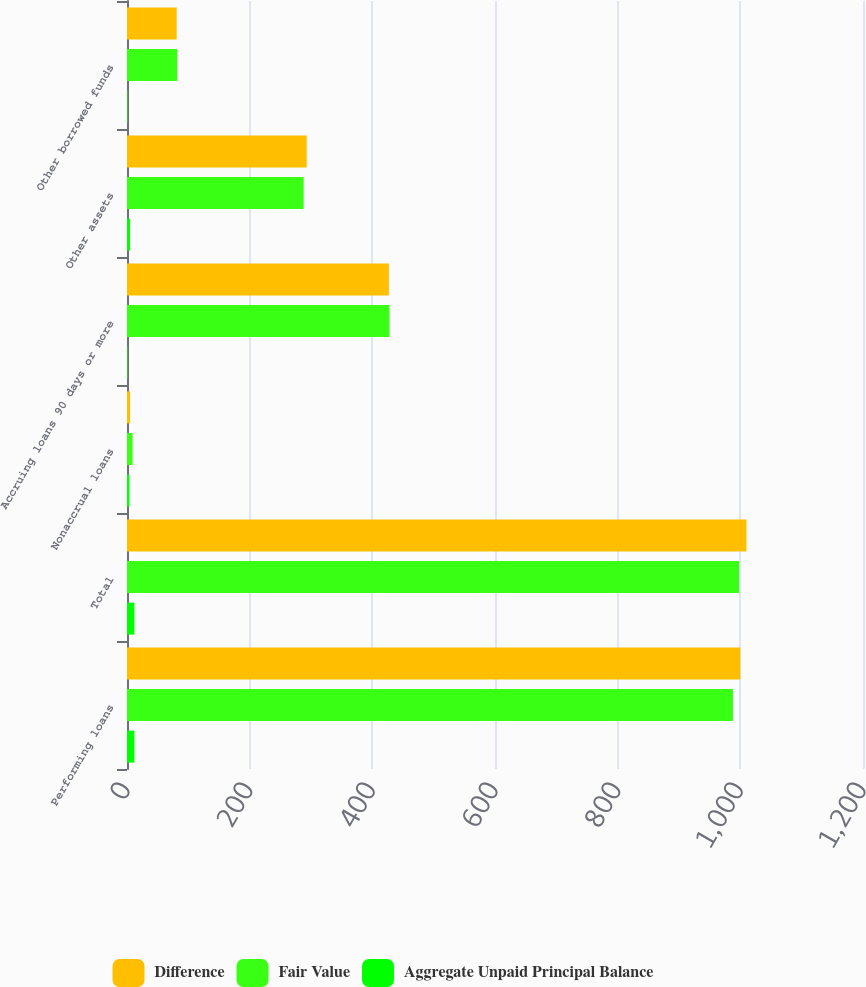Convert chart to OTSL. <chart><loc_0><loc_0><loc_500><loc_500><stacked_bar_chart><ecel><fcel>Performing loans<fcel>Total<fcel>Nonaccrual loans<fcel>Accruing loans 90 days or more<fcel>Other assets<fcel>Other borrowed funds<nl><fcel>Difference<fcel>1000<fcel>1010<fcel>5<fcel>427<fcel>293<fcel>81<nl><fcel>Fair Value<fcel>988<fcel>998<fcel>9<fcel>428<fcel>288<fcel>82<nl><fcel>Aggregate Unpaid Principal Balance<fcel>12<fcel>12<fcel>4<fcel>1<fcel>5<fcel>1<nl></chart> 